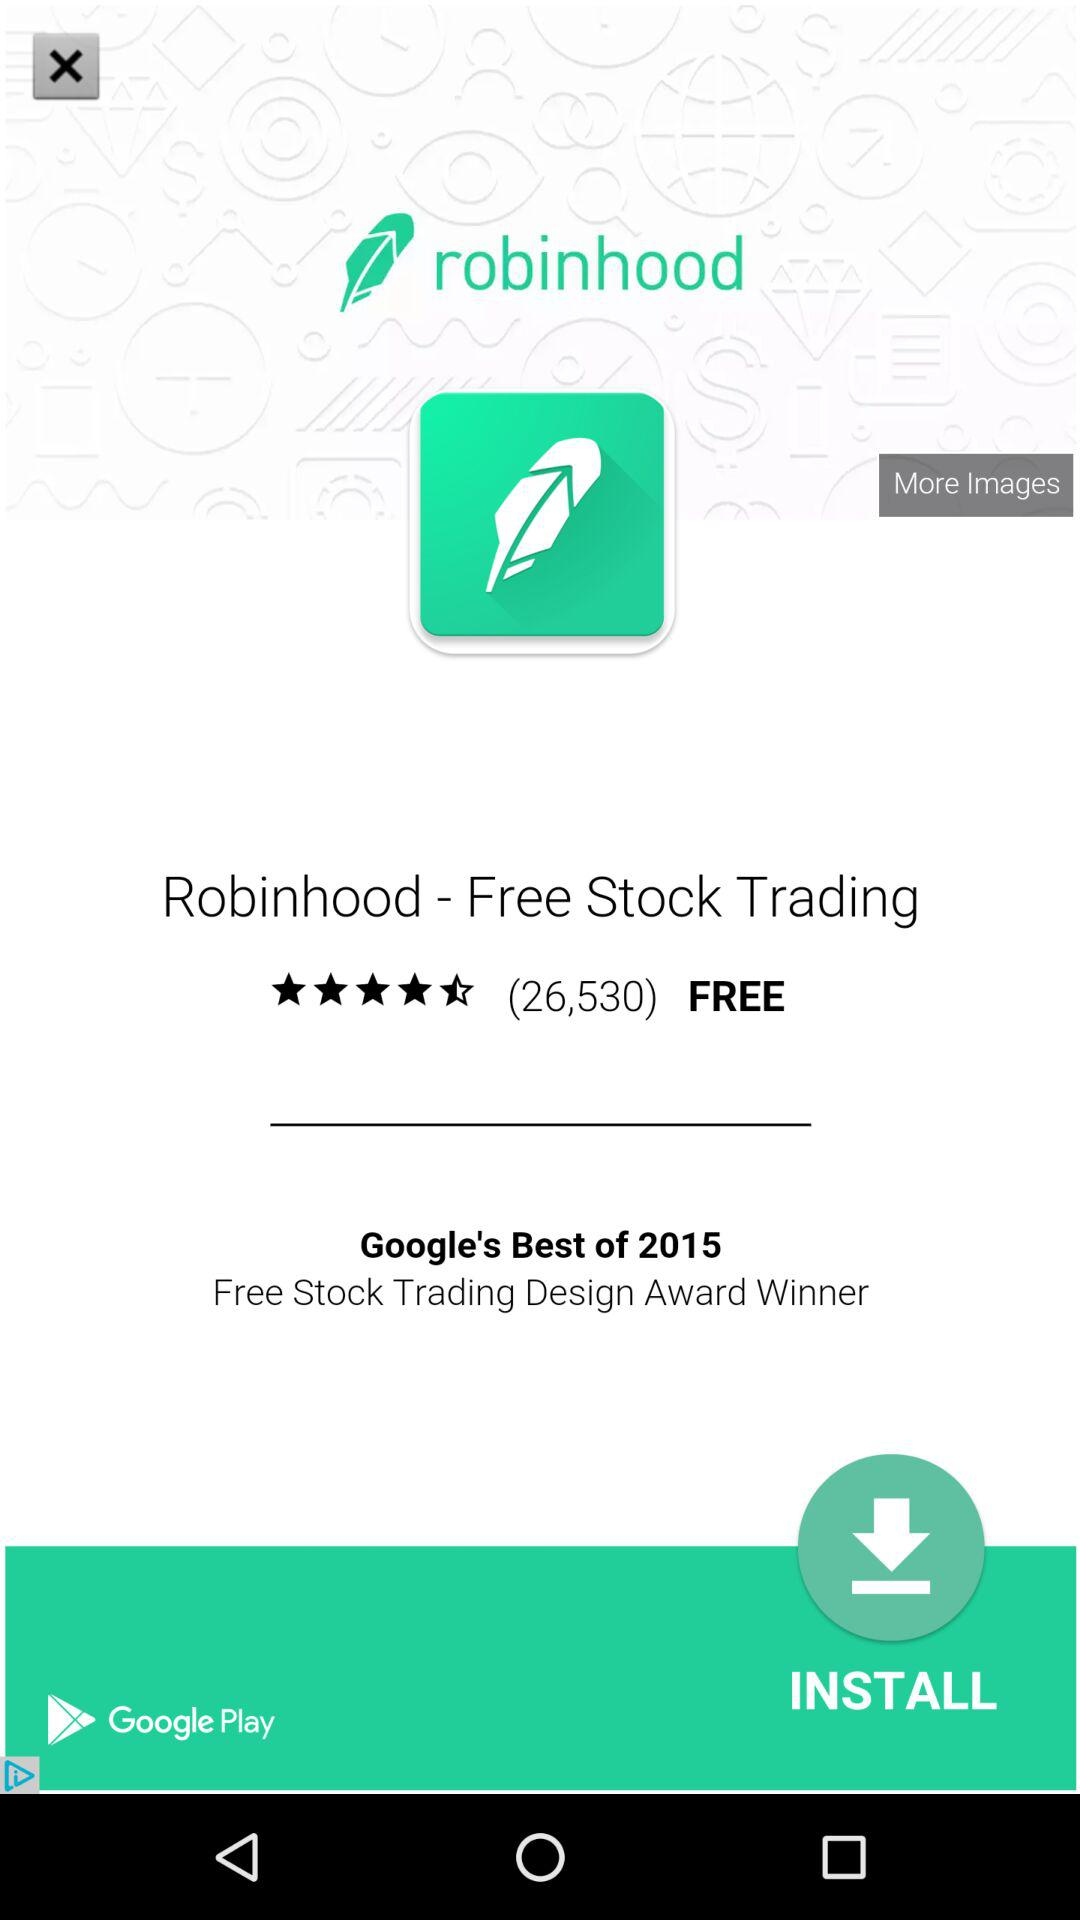What is the rating out of five stars? The rating is 4.5 stars. 